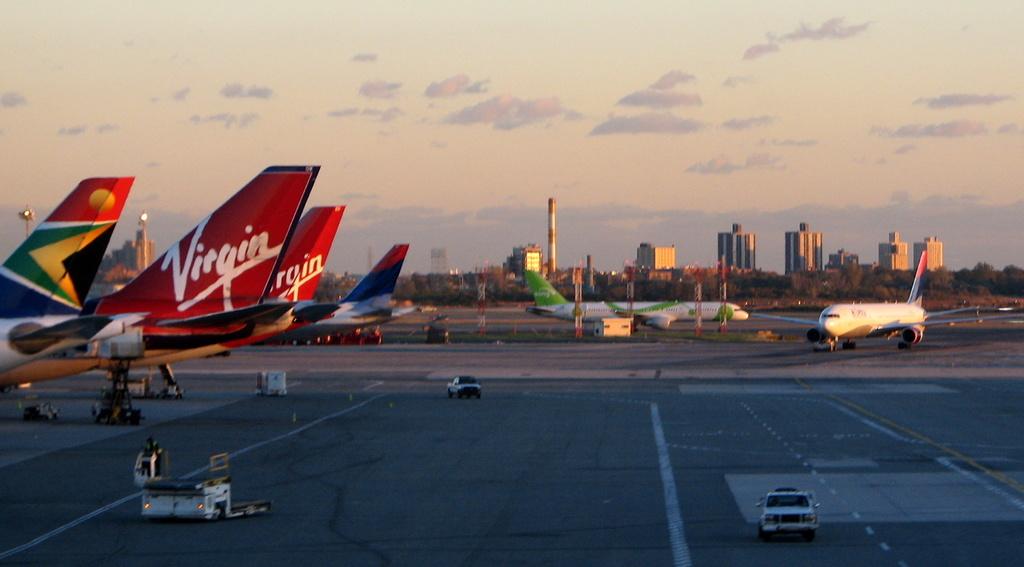What airline is on the left?
Give a very brief answer. Virgin. What type of airline is this?
Offer a terse response. Virgin. 